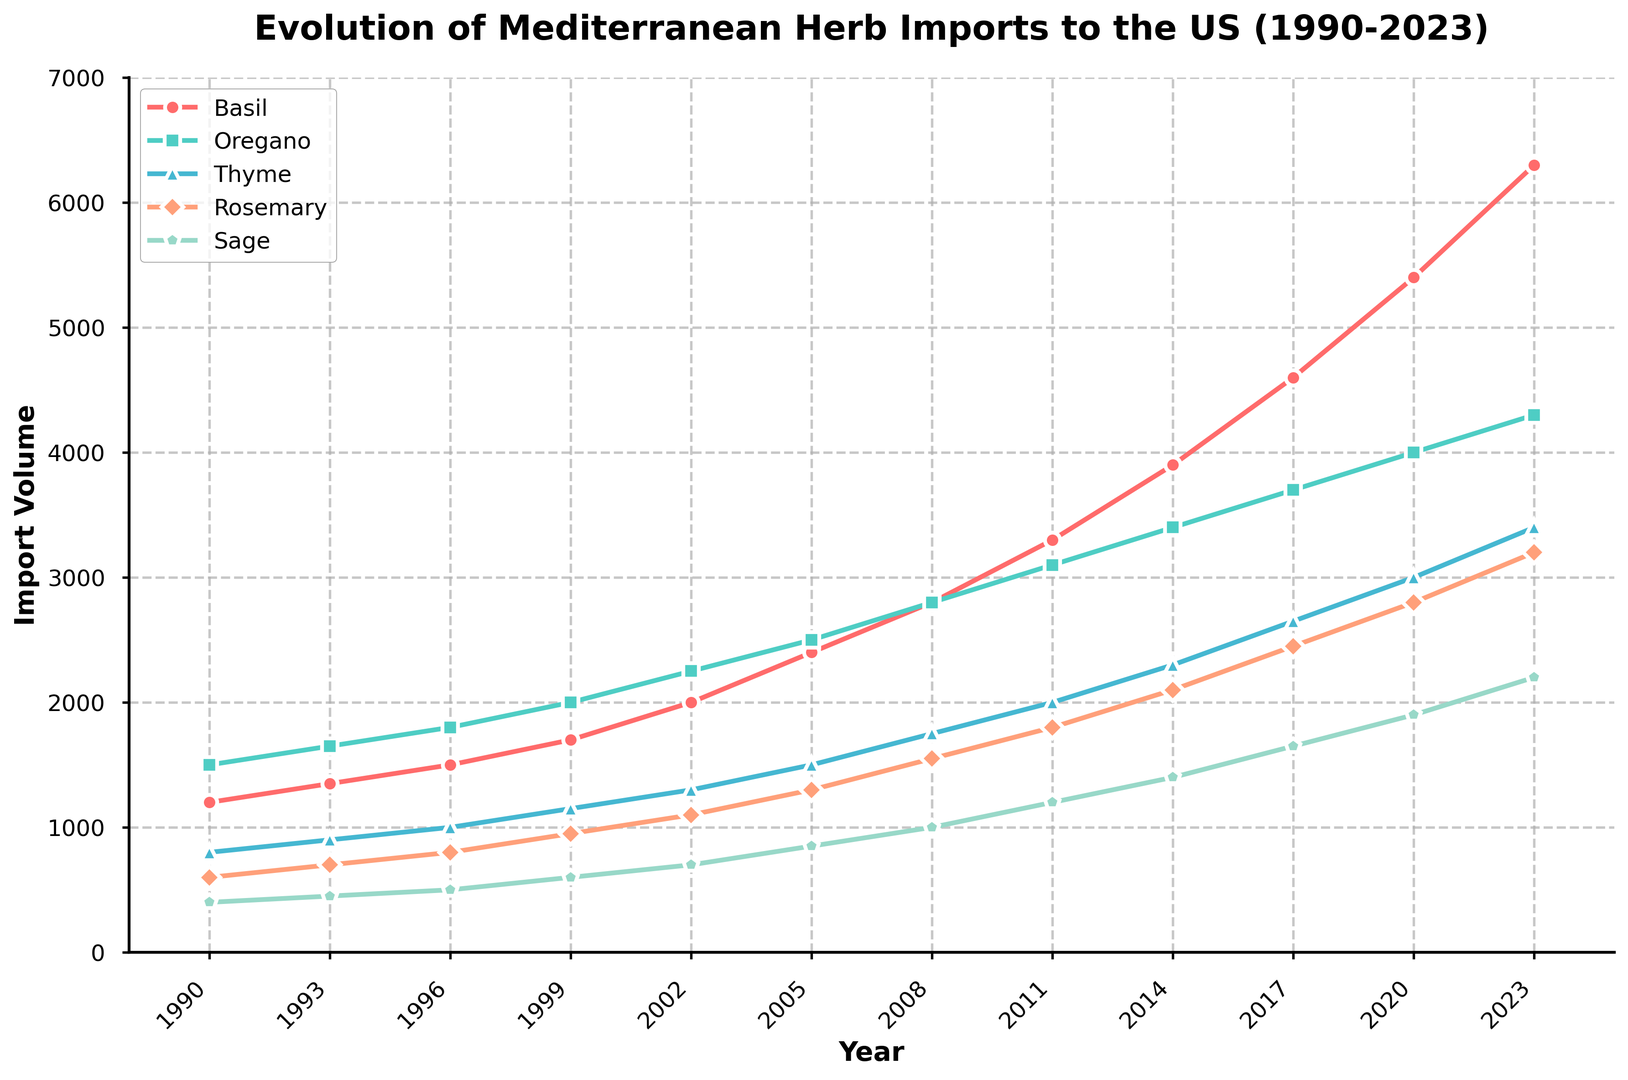Which herb had the highest import volume in 2023? To find the highest import volume for 2023, look at the last data point on each line in the chart. Basil is the herb with the highest import volume reaching 6300 units.
Answer: Basil Which year did Thyme surpass Rosemary in import volume? Look for the intersection point between Thyme and Rosemary lines. Thyme surpasses Rosemary around the year 2005.
Answer: 2005 What has been the overall trend in Basil imports from 1990 to 2023? By observing the slope of the Basil line from 1990 to 2023, it consistently increases, indicating a rising trend.
Answer: Rising What is the difference in import volume of Oregano between 2011 and 2020? Identify the import volumes of Oregano in 2011 (3100) and 2020 (4000). Calculate the difference: 4000 - 3100.
Answer: 900 In which year did Sage imports reach 1400 units? Find where the Sage line reaches the 1400 mark on the Y-axis. This occurs in 2014.
Answer: 2014 Which herb saw the most significant increase in imports between 2017 and 2023? Evaluate the difference between import volumes in 2017 and 2023 for each herb. Basil had the largest increase from 4600 to 6300.
Answer: Basil By how much did the import volume of Rosemary increase from 2002 to 2008? Calculate the difference between the values for Rosemary in 2002 (1100) and 2008 (1550): 1550 - 1100.
Answer: 450 Which herb had a steadier import growth between 1990 and 2023? Look for the most consistently upward-sloping line from 1990 to 2023. Oregano exhibits steady growth throughout the years.
Answer: Oregano How does the import volume of Sage in 1990 compare with Rosemary in the same year? Identify import values for each herb in 1990: Sage (400) and Rosemary (600). Sage's import volume is less.
Answer: Less What is the average import volume of Thyme over all the years presented? Sum the import values of Thyme across all years and divide by the number of years: (800+900+1000+1150+1300+1500+1750+2000+2300+2650+3000+3400)/12.
Answer: 1800 